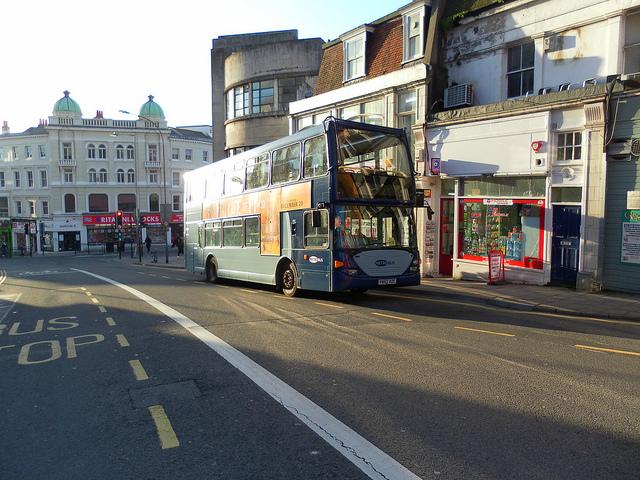Is a bus stop visible?
Answer briefly. Yes. Are many people waiting?
Give a very brief answer. 0. Is this the country or city?
Quick response, please. City. What kind of bus is this?
Keep it brief. Double decker. What color is the double decker bus?
Keep it brief. Blue. Are people on the sidewalk?
Write a very short answer. Yes. Are there vehicles going in both directions?
Answer briefly. No. Is the bus running?
Quick response, please. Yes. What color is the bus?
Short answer required. Blue. What color is the unbroken line?
Answer briefly. White. 